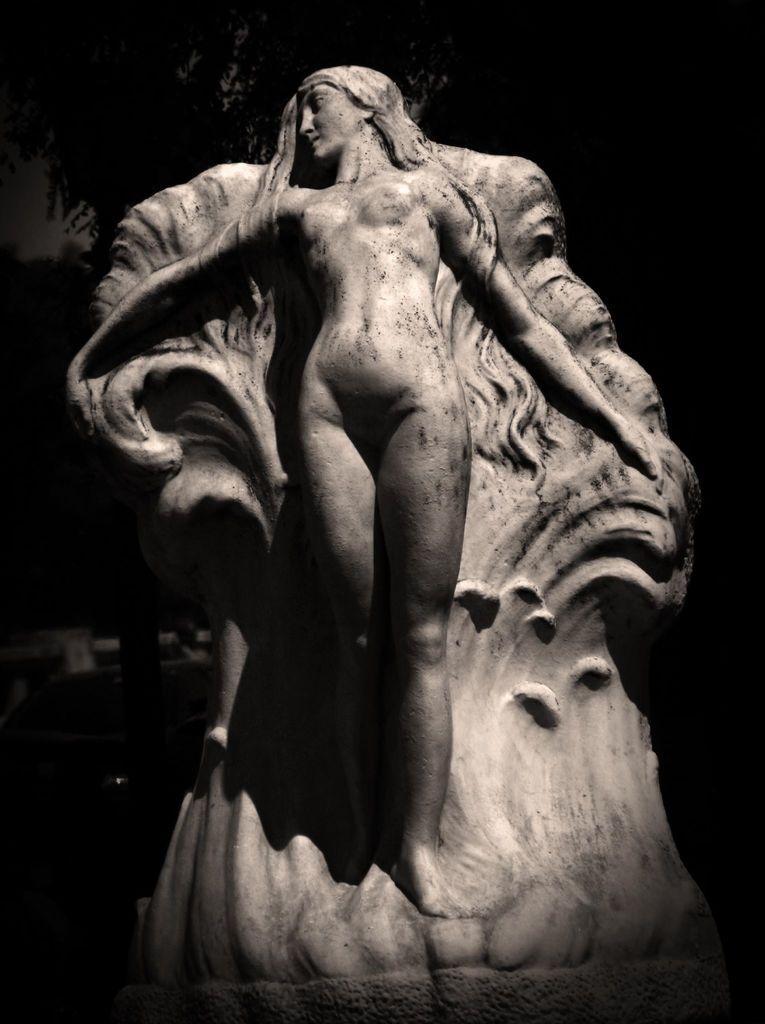Describe this image in one or two sentences. In this image we can see the sculpture of a person. There is a dark background in the image. 